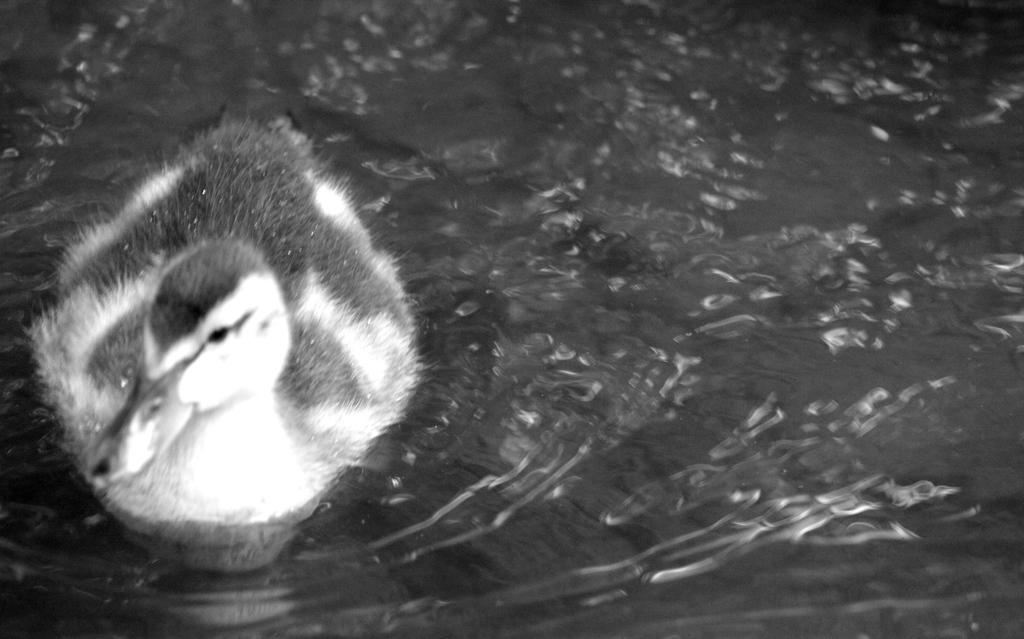What animal is present in the image? There is a duck in the image. What is the duck doing in the image? The duck is swimming in the water. What is the color scheme of the image? The image is black and white. What does the duck's mom look like in the image? There is no mention of a duck's mom in the image, and therefore we cannot describe her appearance. 